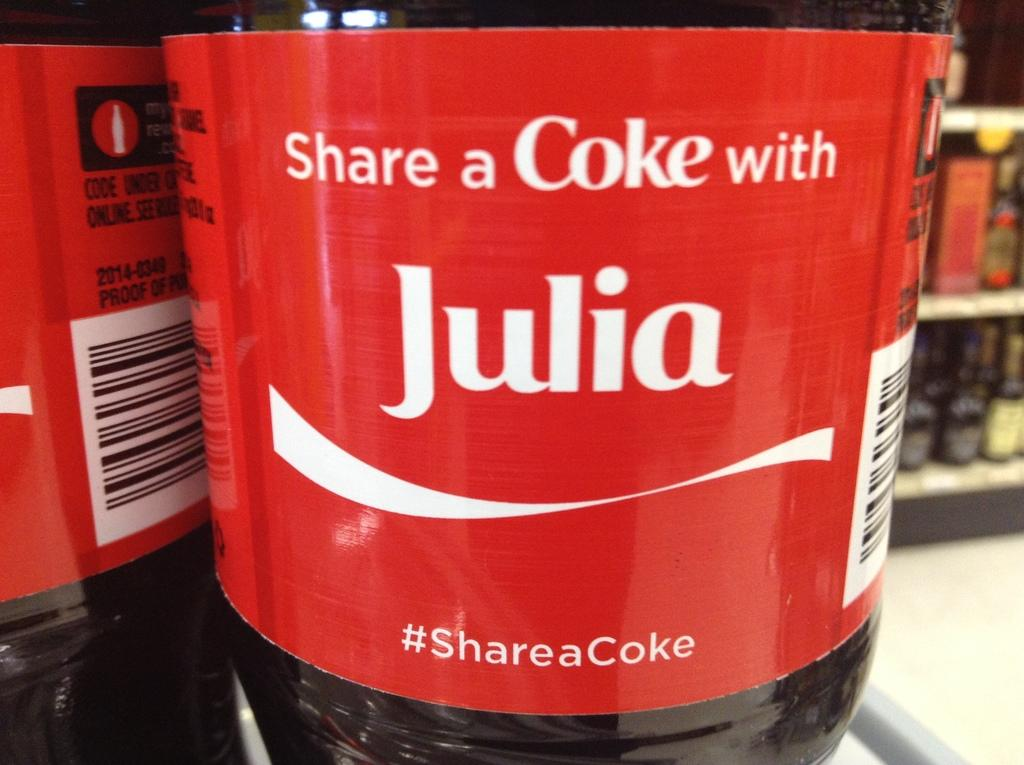<image>
Describe the image concisely. A Coke bottle label is personalized for someone named Julia. 